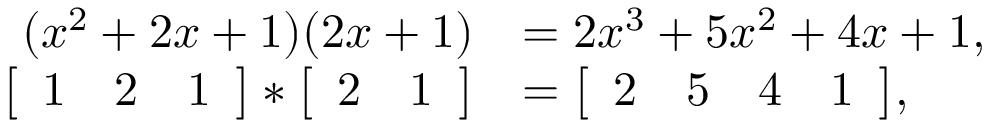<formula> <loc_0><loc_0><loc_500><loc_500>\begin{array} { r l } { ( x ^ { 2 } + 2 x + 1 ) ( 2 x + 1 ) } & { = 2 x ^ { 3 } + 5 x ^ { 2 } + 4 x + 1 , } \\ { \left [ \begin{array} { c c c } { 1 } & { 2 } & { 1 } \end{array} \right ] * \left [ \begin{array} { c c } { 2 } & { 1 } \end{array} \right ] } & { = \left [ \begin{array} { c c c c } { 2 } & { 5 } & { 4 } & { 1 } \end{array} \right ] , } \end{array}</formula> 